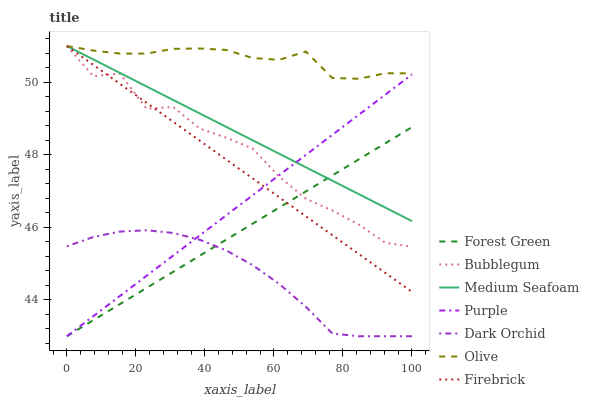Does Dark Orchid have the minimum area under the curve?
Answer yes or no. Yes. Does Olive have the maximum area under the curve?
Answer yes or no. Yes. Does Firebrick have the minimum area under the curve?
Answer yes or no. No. Does Firebrick have the maximum area under the curve?
Answer yes or no. No. Is Firebrick the smoothest?
Answer yes or no. Yes. Is Bubblegum the roughest?
Answer yes or no. Yes. Is Dark Orchid the smoothest?
Answer yes or no. No. Is Dark Orchid the roughest?
Answer yes or no. No. Does Purple have the lowest value?
Answer yes or no. Yes. Does Firebrick have the lowest value?
Answer yes or no. No. Does Medium Seafoam have the highest value?
Answer yes or no. Yes. Does Dark Orchid have the highest value?
Answer yes or no. No. Is Purple less than Olive?
Answer yes or no. Yes. Is Bubblegum greater than Dark Orchid?
Answer yes or no. Yes. Does Firebrick intersect Medium Seafoam?
Answer yes or no. Yes. Is Firebrick less than Medium Seafoam?
Answer yes or no. No. Is Firebrick greater than Medium Seafoam?
Answer yes or no. No. Does Purple intersect Olive?
Answer yes or no. No. 